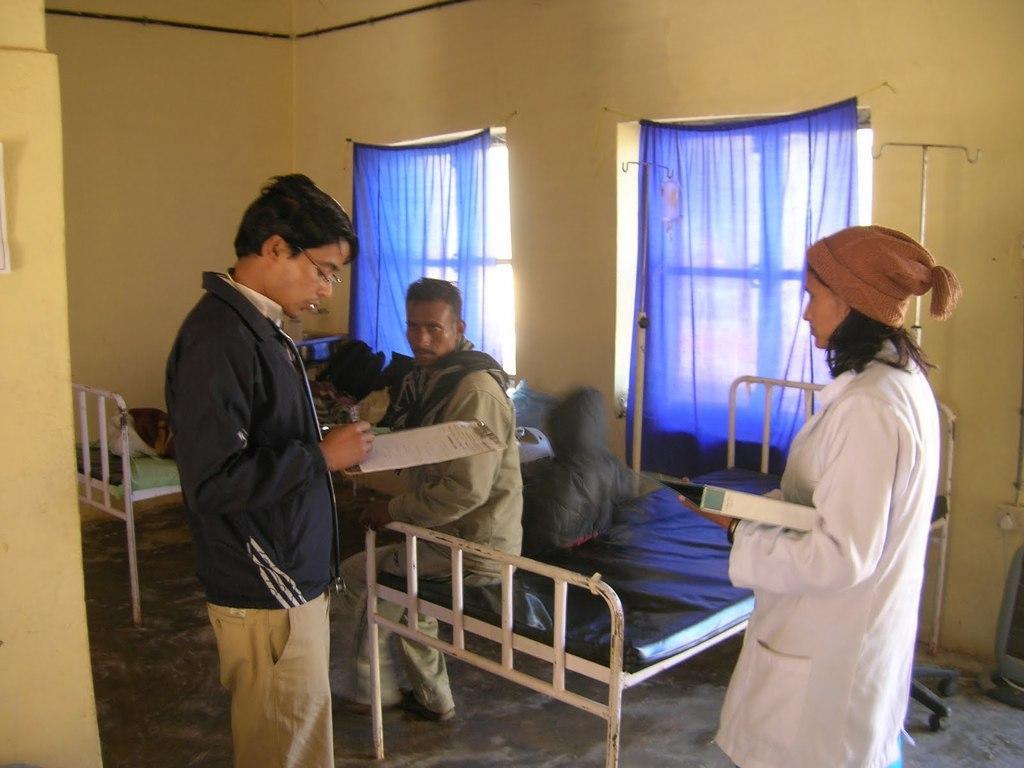Describe this image in one or two sentences. These are windows with curtains. These are beds. These 2 persons are standing and holding a pad. This woman wore white coat. This man wore a jacket. This person is sitting on a bed. 